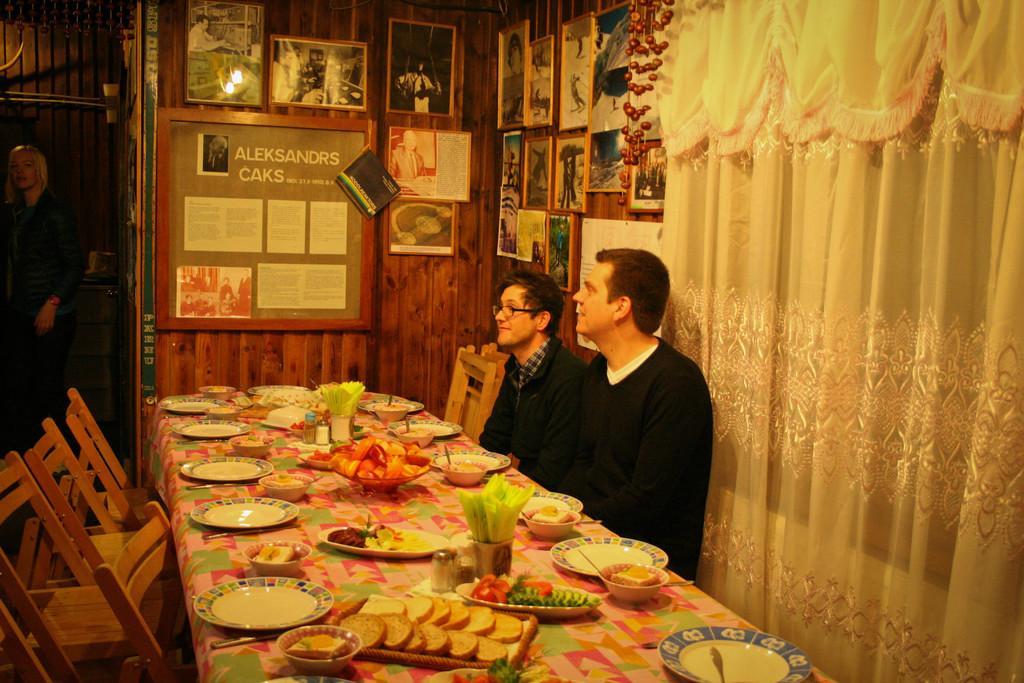How would you summarize this image in a sentence or two? This picture is clicked inside. On the right we can see the two persons sitting on the chairs. On the left there is a person standing on the ground and we can see the wooden chairs. In the center there is a table on the top of which plates, tissue papers, bowls containing food items, bottles and platters of food items are placed. In the background we can see the curtain, picture frames hanging on the wall and there is a poster attached to the wall on which we can see the text and some pictures and we can see an object hanging on the roof. 